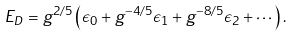<formula> <loc_0><loc_0><loc_500><loc_500>E _ { D } = g ^ { 2 / 5 } \left ( \epsilon _ { 0 } + g ^ { - 4 / 5 } \epsilon _ { 1 } + g ^ { - 8 / 5 } \epsilon _ { 2 } + \cdots \right ) .</formula> 